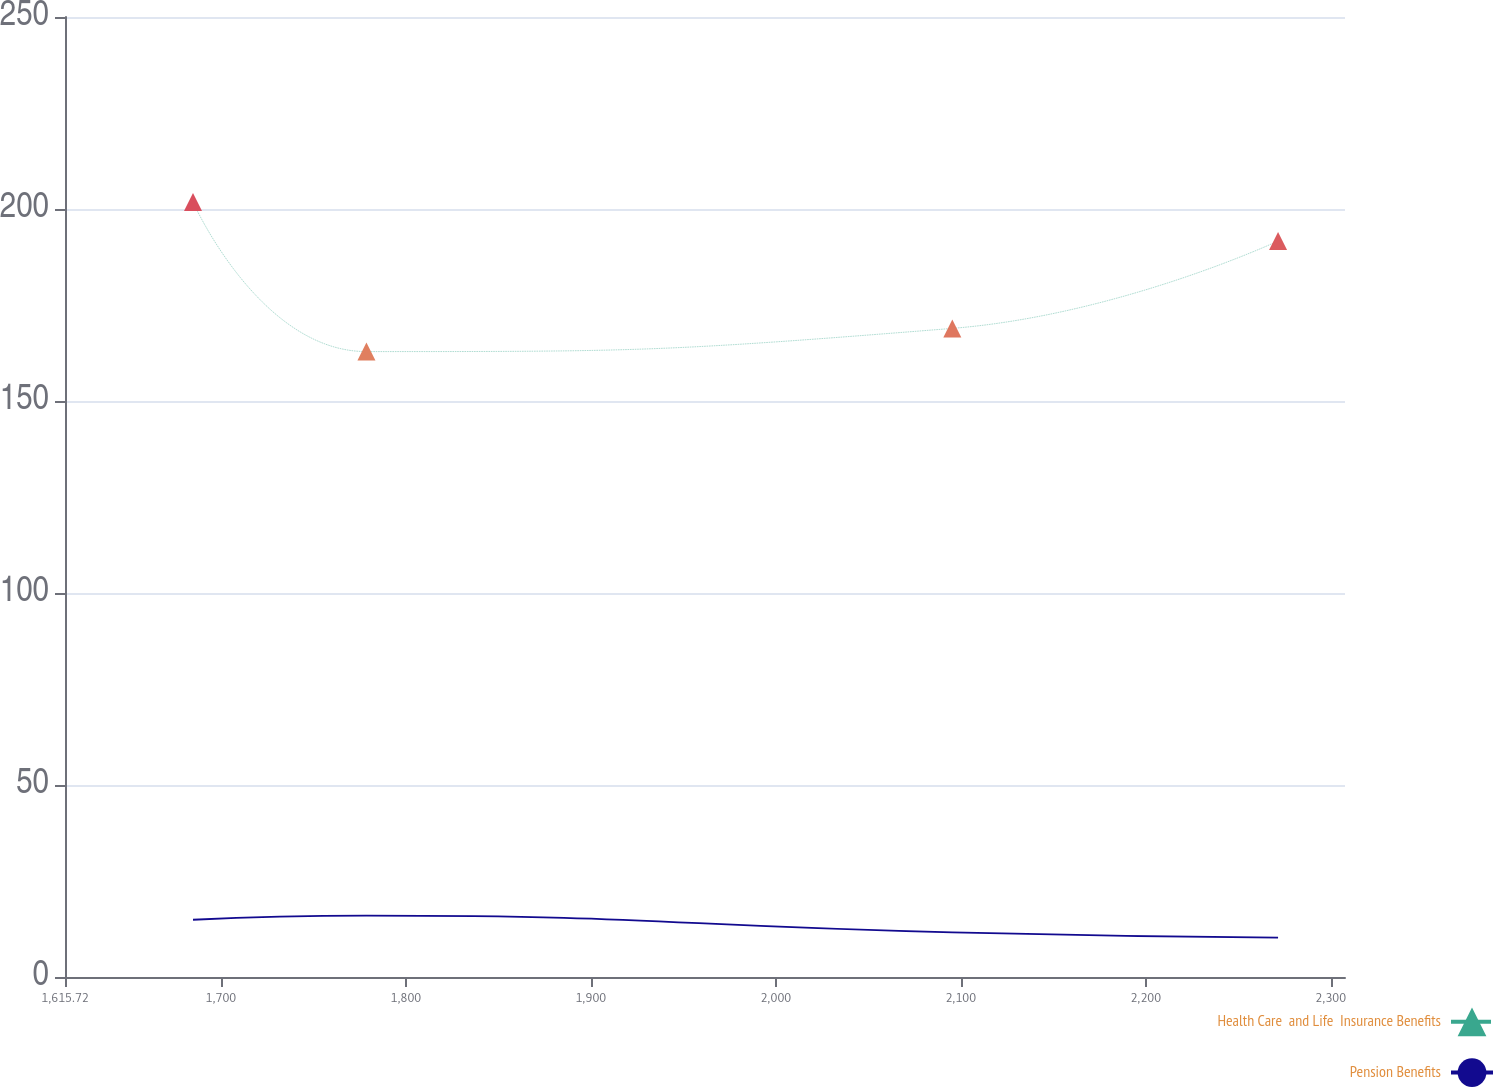Convert chart. <chart><loc_0><loc_0><loc_500><loc_500><line_chart><ecel><fcel>Health Care  and Life  Insurance Benefits<fcel>Pension Benefits<nl><fcel>1684.92<fcel>201.81<fcel>14.91<nl><fcel>1778.68<fcel>162.87<fcel>15.98<nl><fcel>2095.42<fcel>168.91<fcel>11.63<nl><fcel>2271.53<fcel>191.67<fcel>10.25<nl><fcel>2376.92<fcel>156.61<fcel>9.34<nl></chart> 